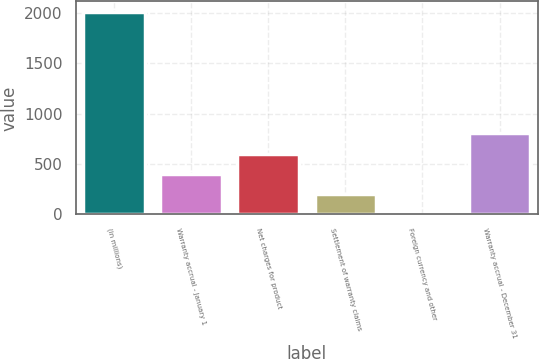Convert chart. <chart><loc_0><loc_0><loc_500><loc_500><bar_chart><fcel>(in millions)<fcel>Warranty accrual - January 1<fcel>Net charges for product<fcel>Settlement of warranty claims<fcel>Foreign currency and other<fcel>Warranty accrual - December 31<nl><fcel>2015<fcel>403.8<fcel>605.2<fcel>202.4<fcel>1<fcel>806.6<nl></chart> 